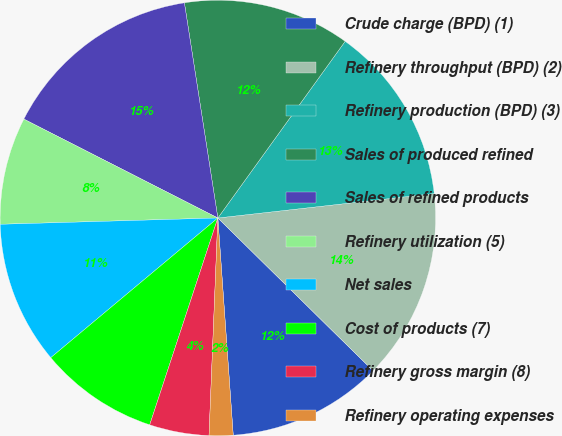Convert chart to OTSL. <chart><loc_0><loc_0><loc_500><loc_500><pie_chart><fcel>Crude charge (BPD) (1)<fcel>Refinery throughput (BPD) (2)<fcel>Refinery production (BPD) (3)<fcel>Sales of produced refined<fcel>Sales of refined products<fcel>Refinery utilization (5)<fcel>Net sales<fcel>Cost of products (7)<fcel>Refinery gross margin (8)<fcel>Refinery operating expenses<nl><fcel>11.5%<fcel>14.16%<fcel>13.27%<fcel>12.39%<fcel>15.04%<fcel>7.96%<fcel>10.62%<fcel>8.85%<fcel>4.42%<fcel>1.77%<nl></chart> 